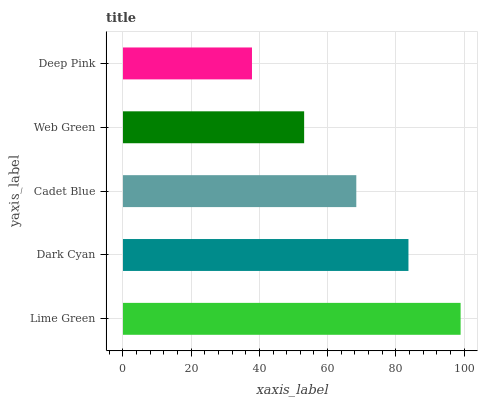Is Deep Pink the minimum?
Answer yes or no. Yes. Is Lime Green the maximum?
Answer yes or no. Yes. Is Dark Cyan the minimum?
Answer yes or no. No. Is Dark Cyan the maximum?
Answer yes or no. No. Is Lime Green greater than Dark Cyan?
Answer yes or no. Yes. Is Dark Cyan less than Lime Green?
Answer yes or no. Yes. Is Dark Cyan greater than Lime Green?
Answer yes or no. No. Is Lime Green less than Dark Cyan?
Answer yes or no. No. Is Cadet Blue the high median?
Answer yes or no. Yes. Is Cadet Blue the low median?
Answer yes or no. Yes. Is Deep Pink the high median?
Answer yes or no. No. Is Dark Cyan the low median?
Answer yes or no. No. 